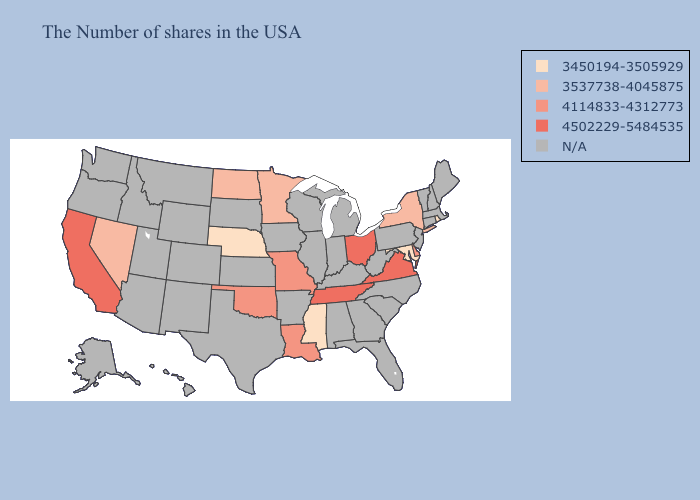Does the first symbol in the legend represent the smallest category?
Write a very short answer. Yes. Which states have the highest value in the USA?
Be succinct. Virginia, Ohio, Tennessee, California. Name the states that have a value in the range 3537738-4045875?
Be succinct. New York, Minnesota, North Dakota, Nevada. Does Louisiana have the lowest value in the South?
Short answer required. No. Among the states that border Tennessee , which have the lowest value?
Quick response, please. Mississippi. What is the value of Arkansas?
Keep it brief. N/A. What is the lowest value in states that border Arkansas?
Concise answer only. 3450194-3505929. Name the states that have a value in the range N/A?
Short answer required. Maine, Massachusetts, New Hampshire, Vermont, Connecticut, New Jersey, Pennsylvania, North Carolina, South Carolina, West Virginia, Florida, Georgia, Michigan, Kentucky, Indiana, Alabama, Wisconsin, Illinois, Arkansas, Iowa, Kansas, Texas, South Dakota, Wyoming, Colorado, New Mexico, Utah, Montana, Arizona, Idaho, Washington, Oregon, Alaska, Hawaii. Name the states that have a value in the range 4502229-5484535?
Answer briefly. Virginia, Ohio, Tennessee, California. What is the value of Texas?
Write a very short answer. N/A. Name the states that have a value in the range 4502229-5484535?
Give a very brief answer. Virginia, Ohio, Tennessee, California. 